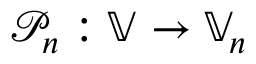<formula> <loc_0><loc_0><loc_500><loc_500>{ \mathcal { P } } _ { n } \colon \mathbb { V } \rightarrow \mathbb { V } _ { n }</formula> 